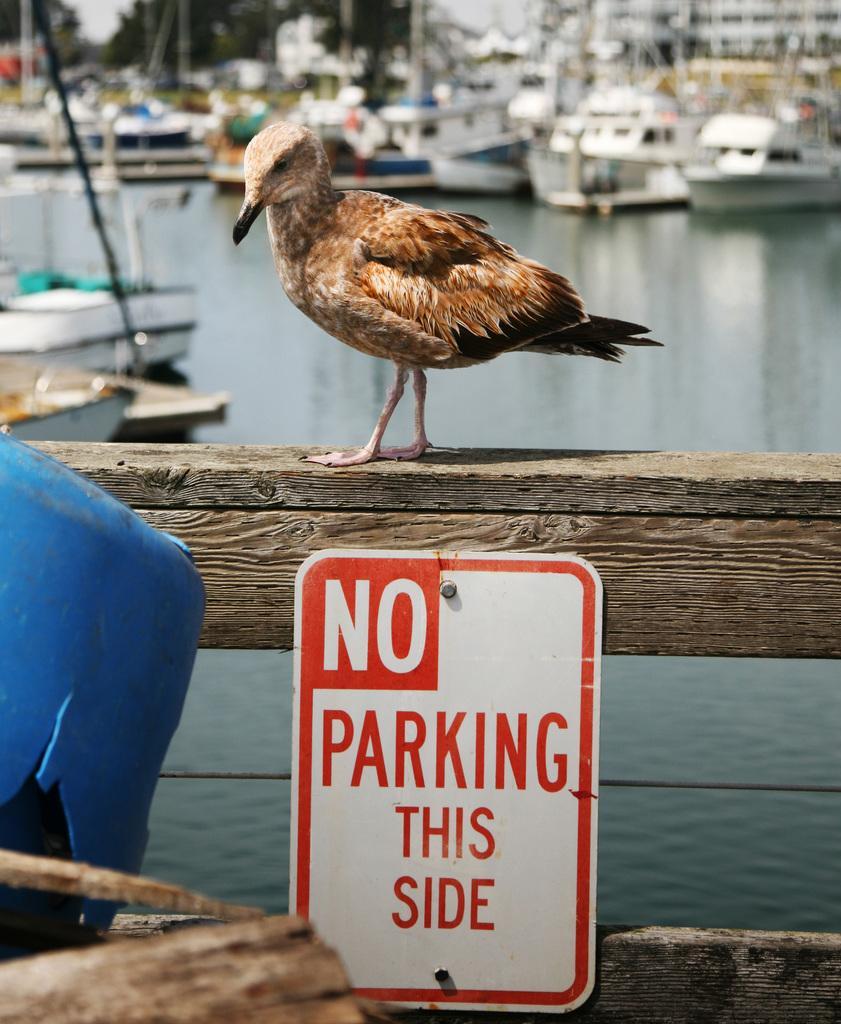Could you give a brief overview of what you see in this image? In this image I can see a board attached to the wooden pole and the board is in white color, in front I can see a bird which is in brown color. Background I can see few ships on the water, trees in green color and sky in white color. 